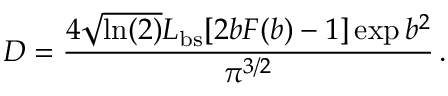Convert formula to latex. <formula><loc_0><loc_0><loc_500><loc_500>D = \frac { 4 \sqrt { \ln ( 2 ) } L _ { b s } [ 2 b F ( b ) - 1 ] \exp { b ^ { 2 } } } { \pi ^ { 3 / 2 } } \, .</formula> 